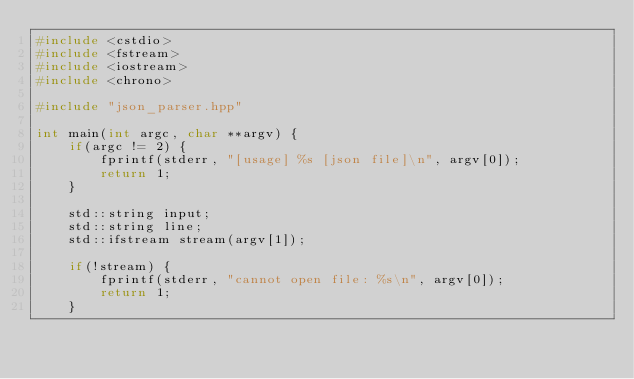Convert code to text. <code><loc_0><loc_0><loc_500><loc_500><_C++_>#include <cstdio>
#include <fstream>
#include <iostream>
#include <chrono>

#include "json_parser.hpp"

int main(int argc, char **argv) {
    if(argc != 2) {
        fprintf(stderr, "[usage] %s [json file]\n", argv[0]);
        return 1;
    }

    std::string input;
    std::string line;
    std::ifstream stream(argv[1]);

    if(!stream) {
        fprintf(stderr, "cannot open file: %s\n", argv[0]);
        return 1;
    }
</code> 